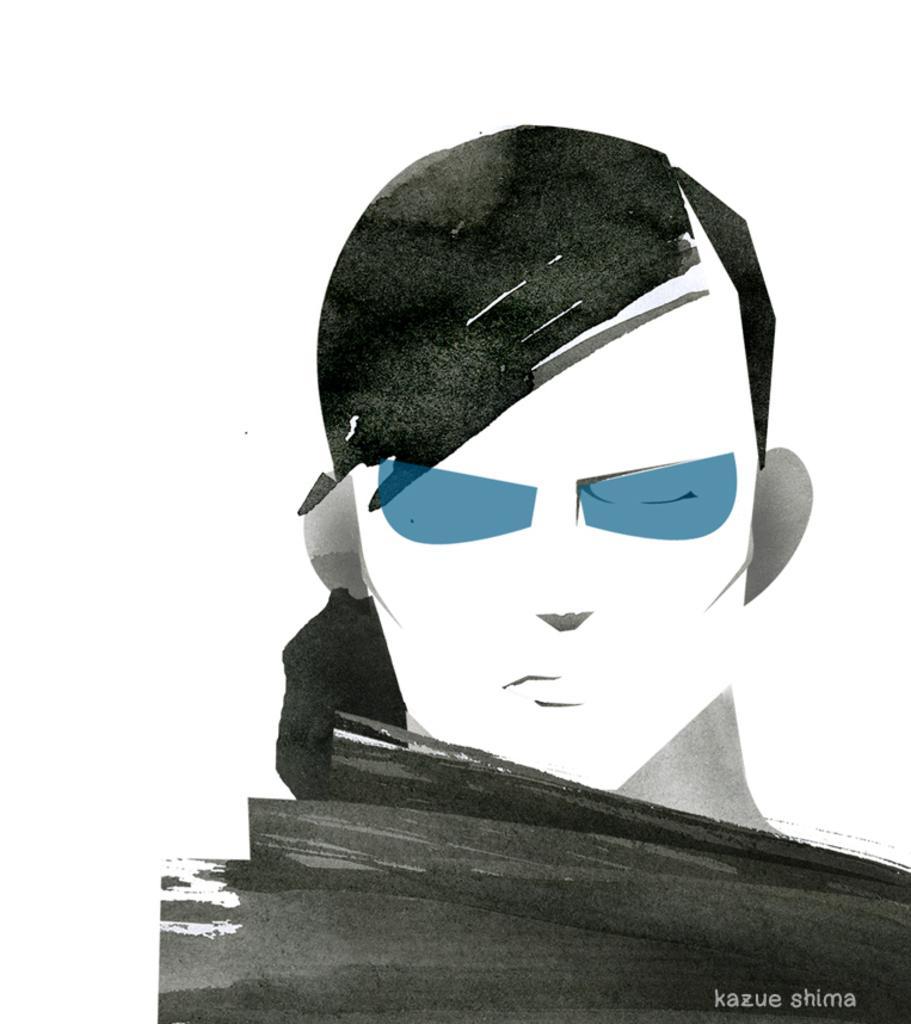In one or two sentences, can you explain what this image depicts? In this image we can see a sketch of a person. 